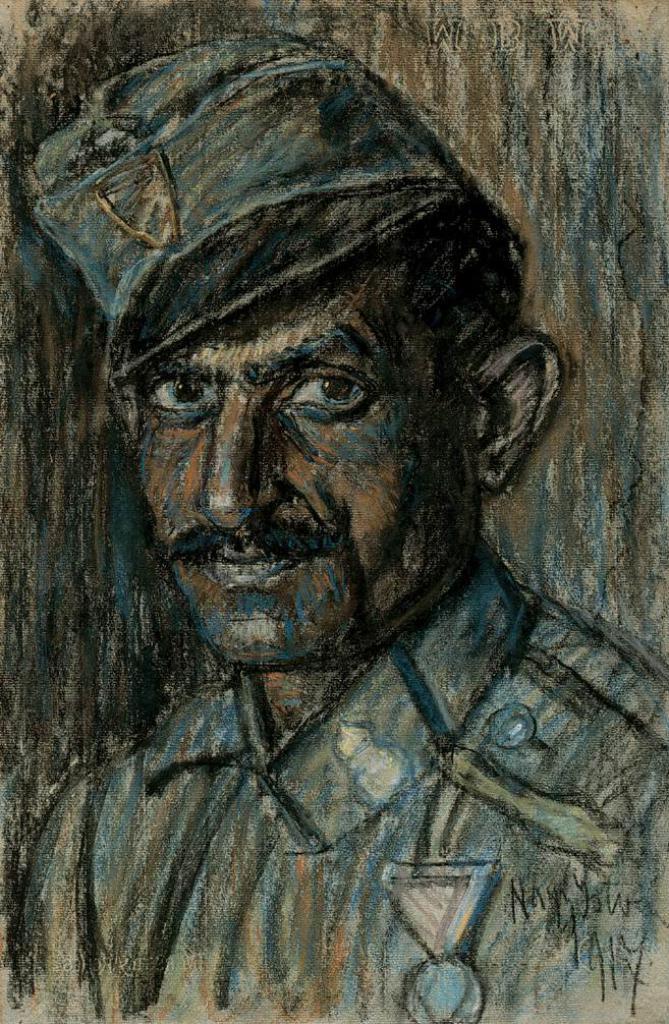How would you summarize this image in a sentence or two? This is a painting in this image, in the center there is one person. 